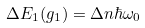Convert formula to latex. <formula><loc_0><loc_0><loc_500><loc_500>\Delta E _ { 1 } ( g _ { 1 } ) = \Delta n \hbar { \omega } _ { 0 }</formula> 